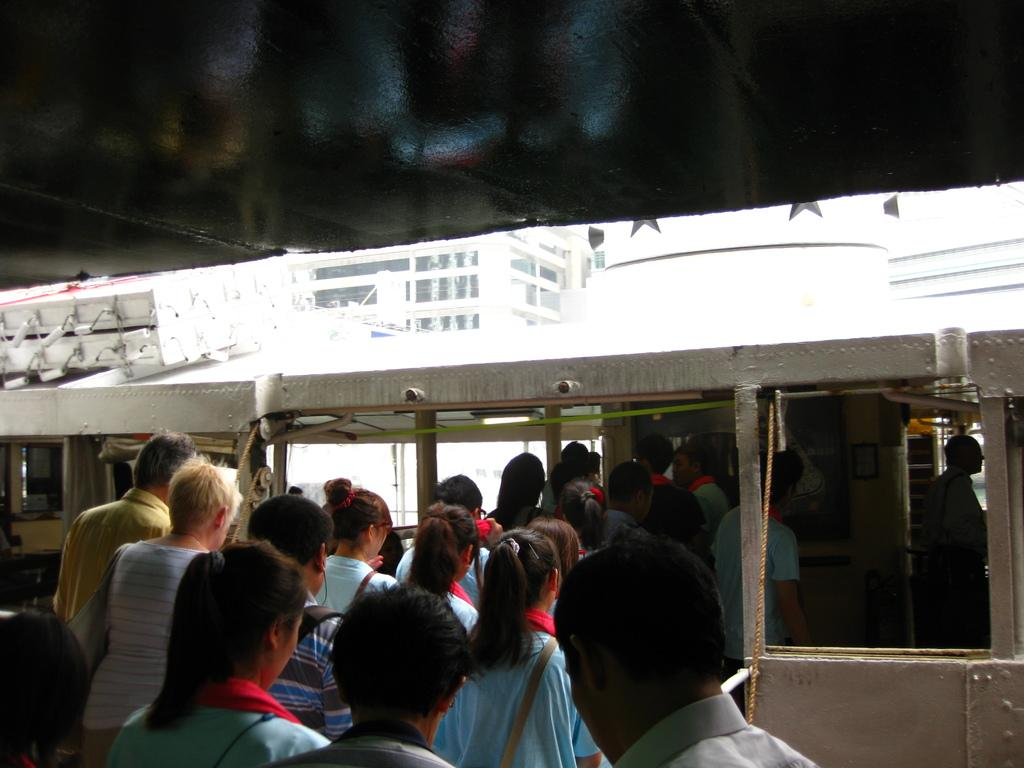How many people are in the group visible in the image? There is a group of people standing in the image, but the exact number cannot be determined from the provided facts. What type of vehicle is present in the image? There is a vehicle in the image, but the specific type cannot be determined from the provided facts. What can be seen in the background of the image? There is a building in the background of the image. What type of linen is being used to cover the relation between the people in the image? There is no mention of linen or a relation between the people in the image; the provided facts only mention a group of people standing and a vehicle. 